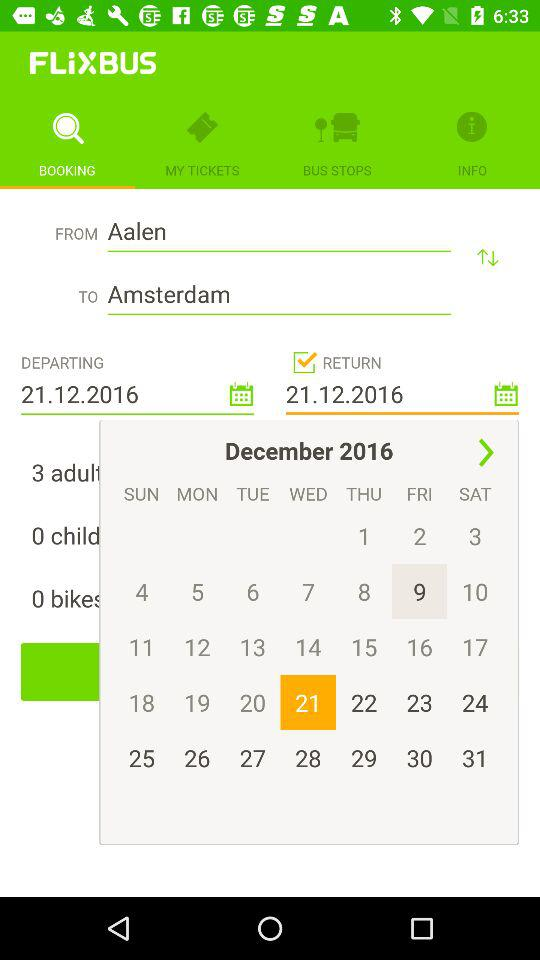Which tab is selected? The selected tab is "BOOKING". 